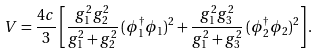Convert formula to latex. <formula><loc_0><loc_0><loc_500><loc_500>V = \frac { 4 c } { 3 } \left [ \frac { g _ { 1 } ^ { 2 } g _ { 2 } ^ { 2 } } { g _ { 1 } ^ { 2 } + g _ { 2 } ^ { 2 } } \, ( \phi _ { 1 } ^ { \dagger } \phi _ { 1 } ) ^ { 2 } + \frac { g _ { 1 } ^ { 2 } g _ { 3 } ^ { 2 } } { g _ { 1 } ^ { 2 } + g _ { 3 } ^ { 2 } } \, ( \phi _ { 2 } ^ { \dagger } \phi _ { 2 } ) ^ { 2 } \right ] .</formula> 